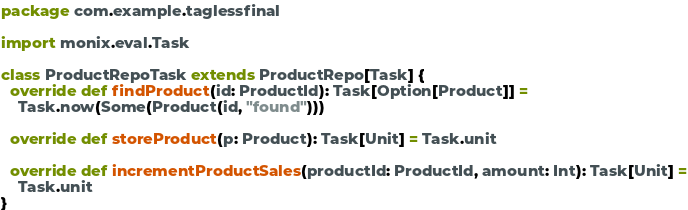Convert code to text. <code><loc_0><loc_0><loc_500><loc_500><_Scala_>package com.example.taglessfinal

import monix.eval.Task

class ProductRepoTask extends ProductRepo[Task] {
  override def findProduct(id: ProductId): Task[Option[Product]] =
    Task.now(Some(Product(id, "found")))

  override def storeProduct(p: Product): Task[Unit] = Task.unit

  override def incrementProductSales(productId: ProductId, amount: Int): Task[Unit] =
    Task.unit
}
</code> 